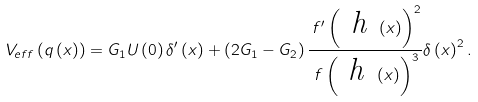<formula> <loc_0><loc_0><loc_500><loc_500>V _ { e f f } \left ( q \left ( x \right ) \right ) = G _ { 1 } U \left ( 0 \right ) \delta ^ { \prime } \left ( x \right ) + \left ( 2 G _ { 1 } - G _ { 2 } \right ) \frac { \, f ^ { \prime } \left ( \emph { h } \left ( x \right ) \right ) ^ { 2 } } { \, f \left ( \emph { h } \left ( x \right ) \right ) ^ { 3 } } \delta \left ( x \right ) ^ { 2 } .</formula> 